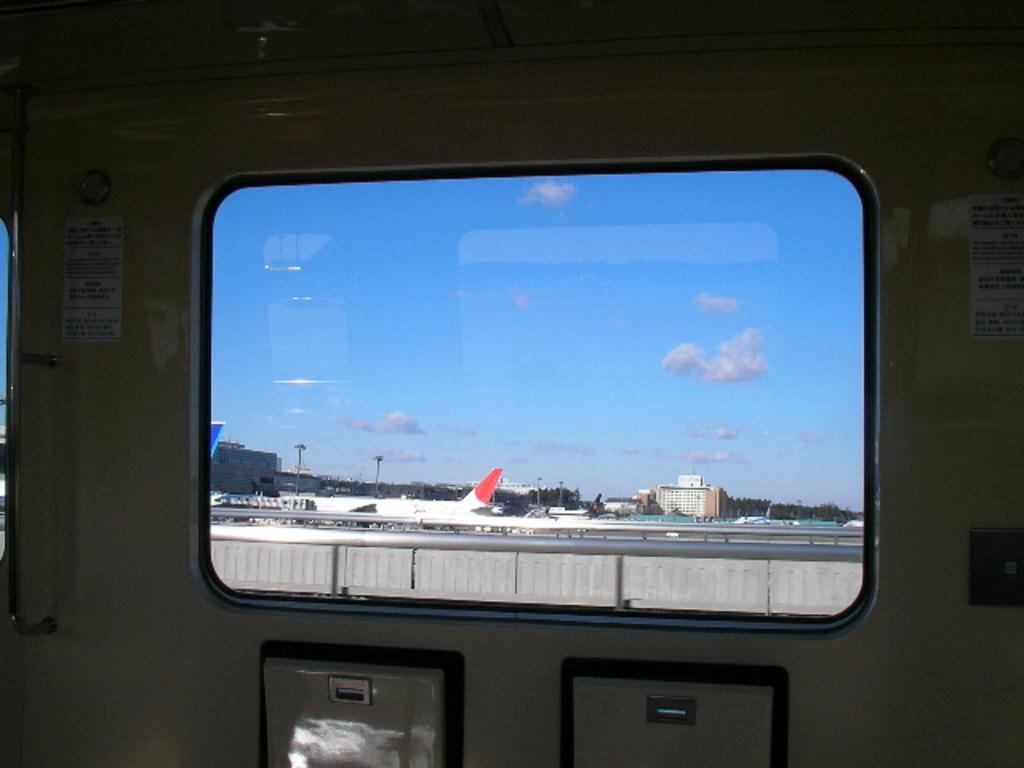What is the main subject of the image? The main subject of the image is an airplane. What can be seen through the windows in the image? The image contains windows, but they do not provide a clear view of the outside. What structures are visible in the image? There are buildings and trees visible in the image. What other objects can be seen in the image? Poles and steel rods are visible in the image. What is visible in the background of the image? The sky is visible in the image. What type of view does the image provide? The image provides an inside view of an airplane. Can you see the ring on the person's finger while they shake hands in the image? There is no person shaking hands or wearing a ring in the image. What type of rock is visible through the window in the image? There is no rock visible through the window in the image; it does not provide a clear view of the outside. 